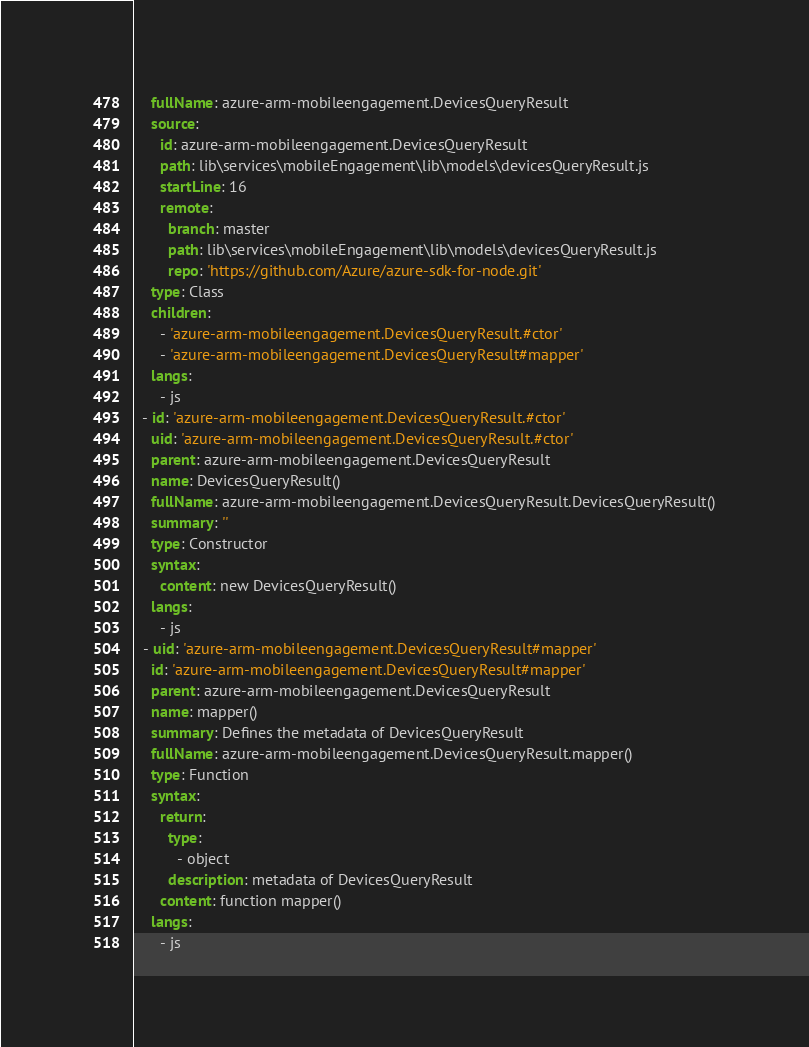Convert code to text. <code><loc_0><loc_0><loc_500><loc_500><_YAML_>    fullName: azure-arm-mobileengagement.DevicesQueryResult
    source:
      id: azure-arm-mobileengagement.DevicesQueryResult
      path: lib\services\mobileEngagement\lib\models\devicesQueryResult.js
      startLine: 16
      remote:
        branch: master
        path: lib\services\mobileEngagement\lib\models\devicesQueryResult.js
        repo: 'https://github.com/Azure/azure-sdk-for-node.git'
    type: Class
    children:
      - 'azure-arm-mobileengagement.DevicesQueryResult.#ctor'
      - 'azure-arm-mobileengagement.DevicesQueryResult#mapper'
    langs:
      - js
  - id: 'azure-arm-mobileengagement.DevicesQueryResult.#ctor'
    uid: 'azure-arm-mobileengagement.DevicesQueryResult.#ctor'
    parent: azure-arm-mobileengagement.DevicesQueryResult
    name: DevicesQueryResult()
    fullName: azure-arm-mobileengagement.DevicesQueryResult.DevicesQueryResult()
    summary: ''
    type: Constructor
    syntax:
      content: new DevicesQueryResult()
    langs:
      - js
  - uid: 'azure-arm-mobileengagement.DevicesQueryResult#mapper'
    id: 'azure-arm-mobileengagement.DevicesQueryResult#mapper'
    parent: azure-arm-mobileengagement.DevicesQueryResult
    name: mapper()
    summary: Defines the metadata of DevicesQueryResult
    fullName: azure-arm-mobileengagement.DevicesQueryResult.mapper()
    type: Function
    syntax:
      return:
        type:
          - object
        description: metadata of DevicesQueryResult
      content: function mapper()
    langs:
      - js
</code> 